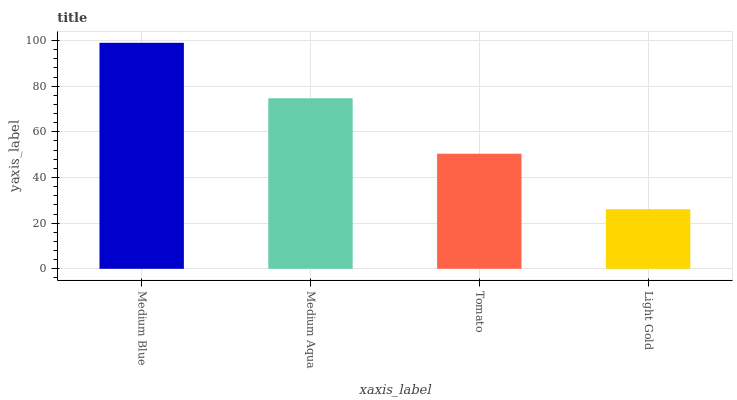Is Light Gold the minimum?
Answer yes or no. Yes. Is Medium Blue the maximum?
Answer yes or no. Yes. Is Medium Aqua the minimum?
Answer yes or no. No. Is Medium Aqua the maximum?
Answer yes or no. No. Is Medium Blue greater than Medium Aqua?
Answer yes or no. Yes. Is Medium Aqua less than Medium Blue?
Answer yes or no. Yes. Is Medium Aqua greater than Medium Blue?
Answer yes or no. No. Is Medium Blue less than Medium Aqua?
Answer yes or no. No. Is Medium Aqua the high median?
Answer yes or no. Yes. Is Tomato the low median?
Answer yes or no. Yes. Is Tomato the high median?
Answer yes or no. No. Is Medium Blue the low median?
Answer yes or no. No. 